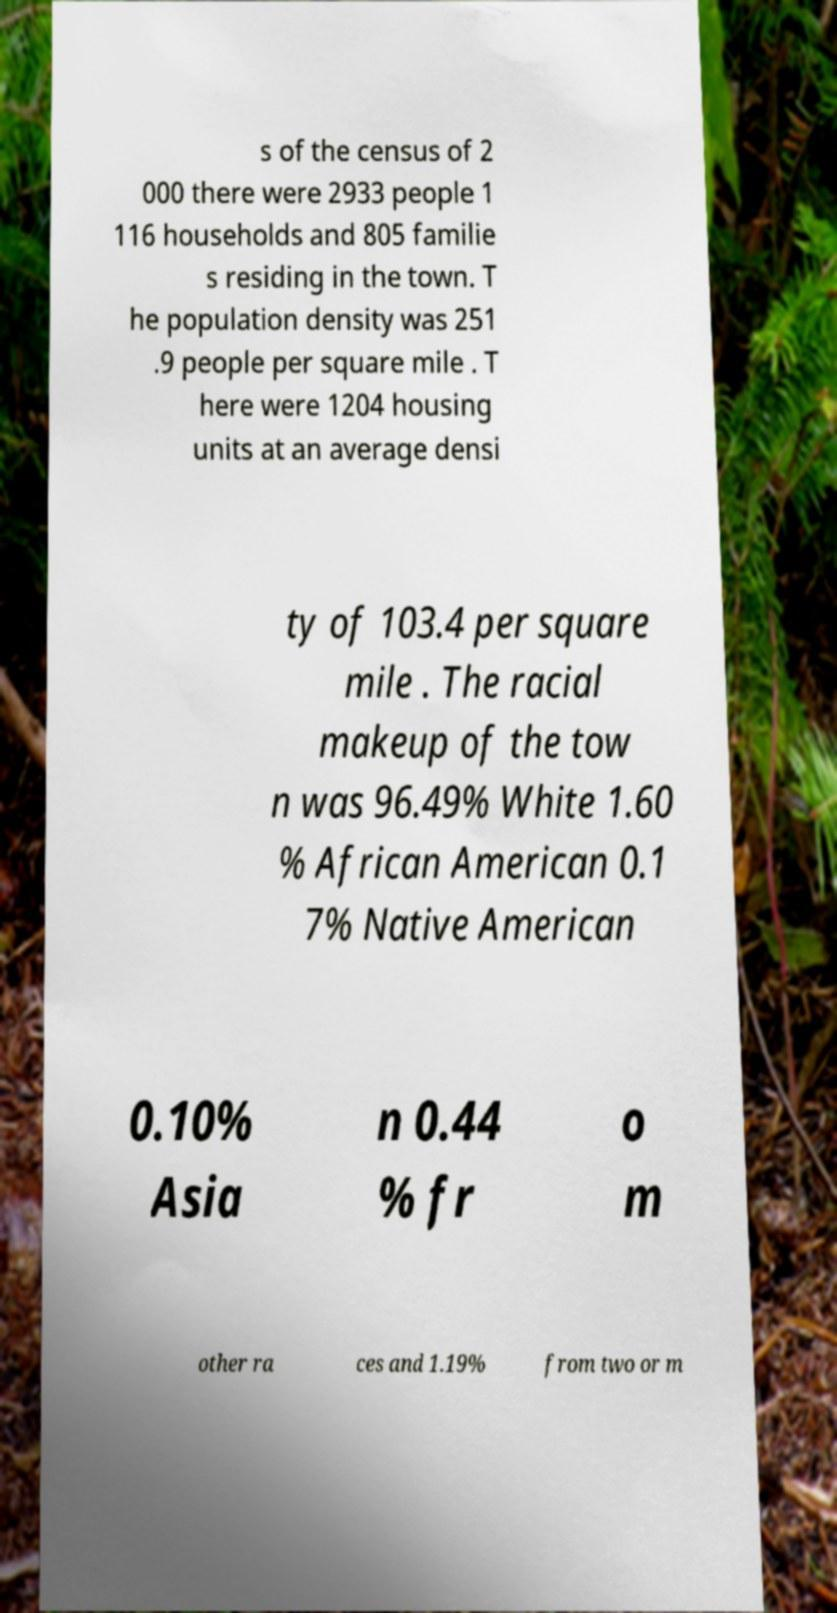Can you accurately transcribe the text from the provided image for me? s of the census of 2 000 there were 2933 people 1 116 households and 805 familie s residing in the town. T he population density was 251 .9 people per square mile . T here were 1204 housing units at an average densi ty of 103.4 per square mile . The racial makeup of the tow n was 96.49% White 1.60 % African American 0.1 7% Native American 0.10% Asia n 0.44 % fr o m other ra ces and 1.19% from two or m 